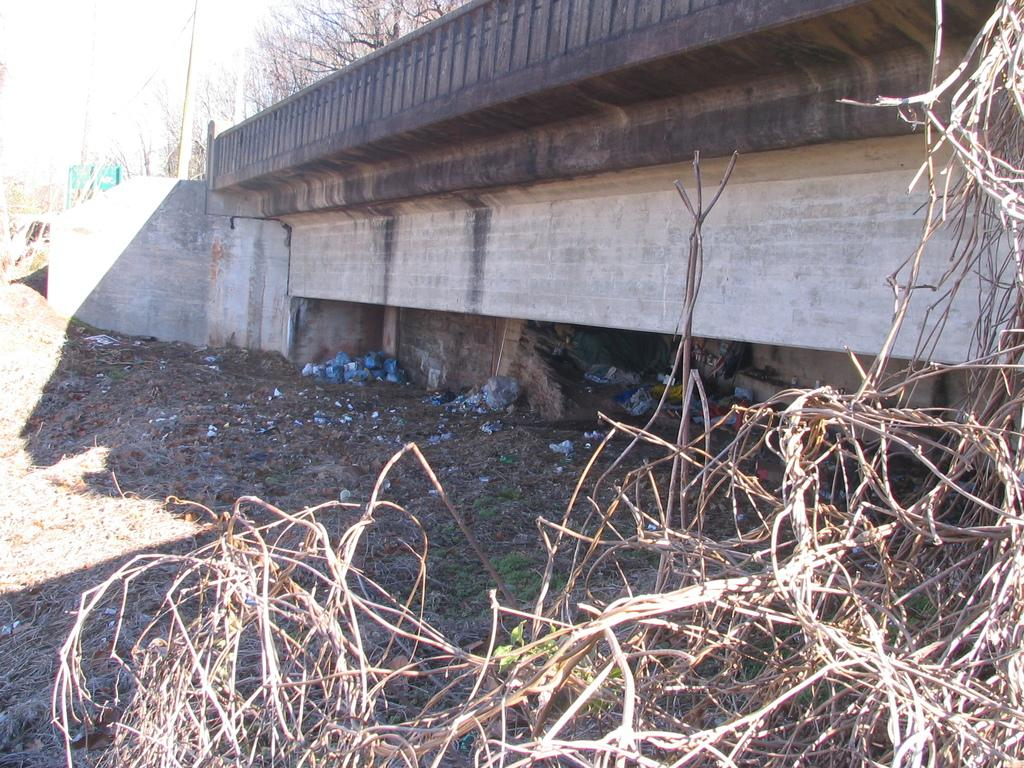What type of structure can be seen in the image? There is a bridge in the image. What type of vegetation is visible in the image? Trees are visible in the image. What type of ground cover is present in the image? Grass is present on the ground in the image. Can you see any arches on the bridge in the image? There is no mention of arches on the bridge in the image, so we cannot determine their presence. 